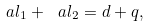Convert formula to latex. <formula><loc_0><loc_0><loc_500><loc_500>\ a l _ { 1 } + \ a l _ { 2 } = d + q ,</formula> 